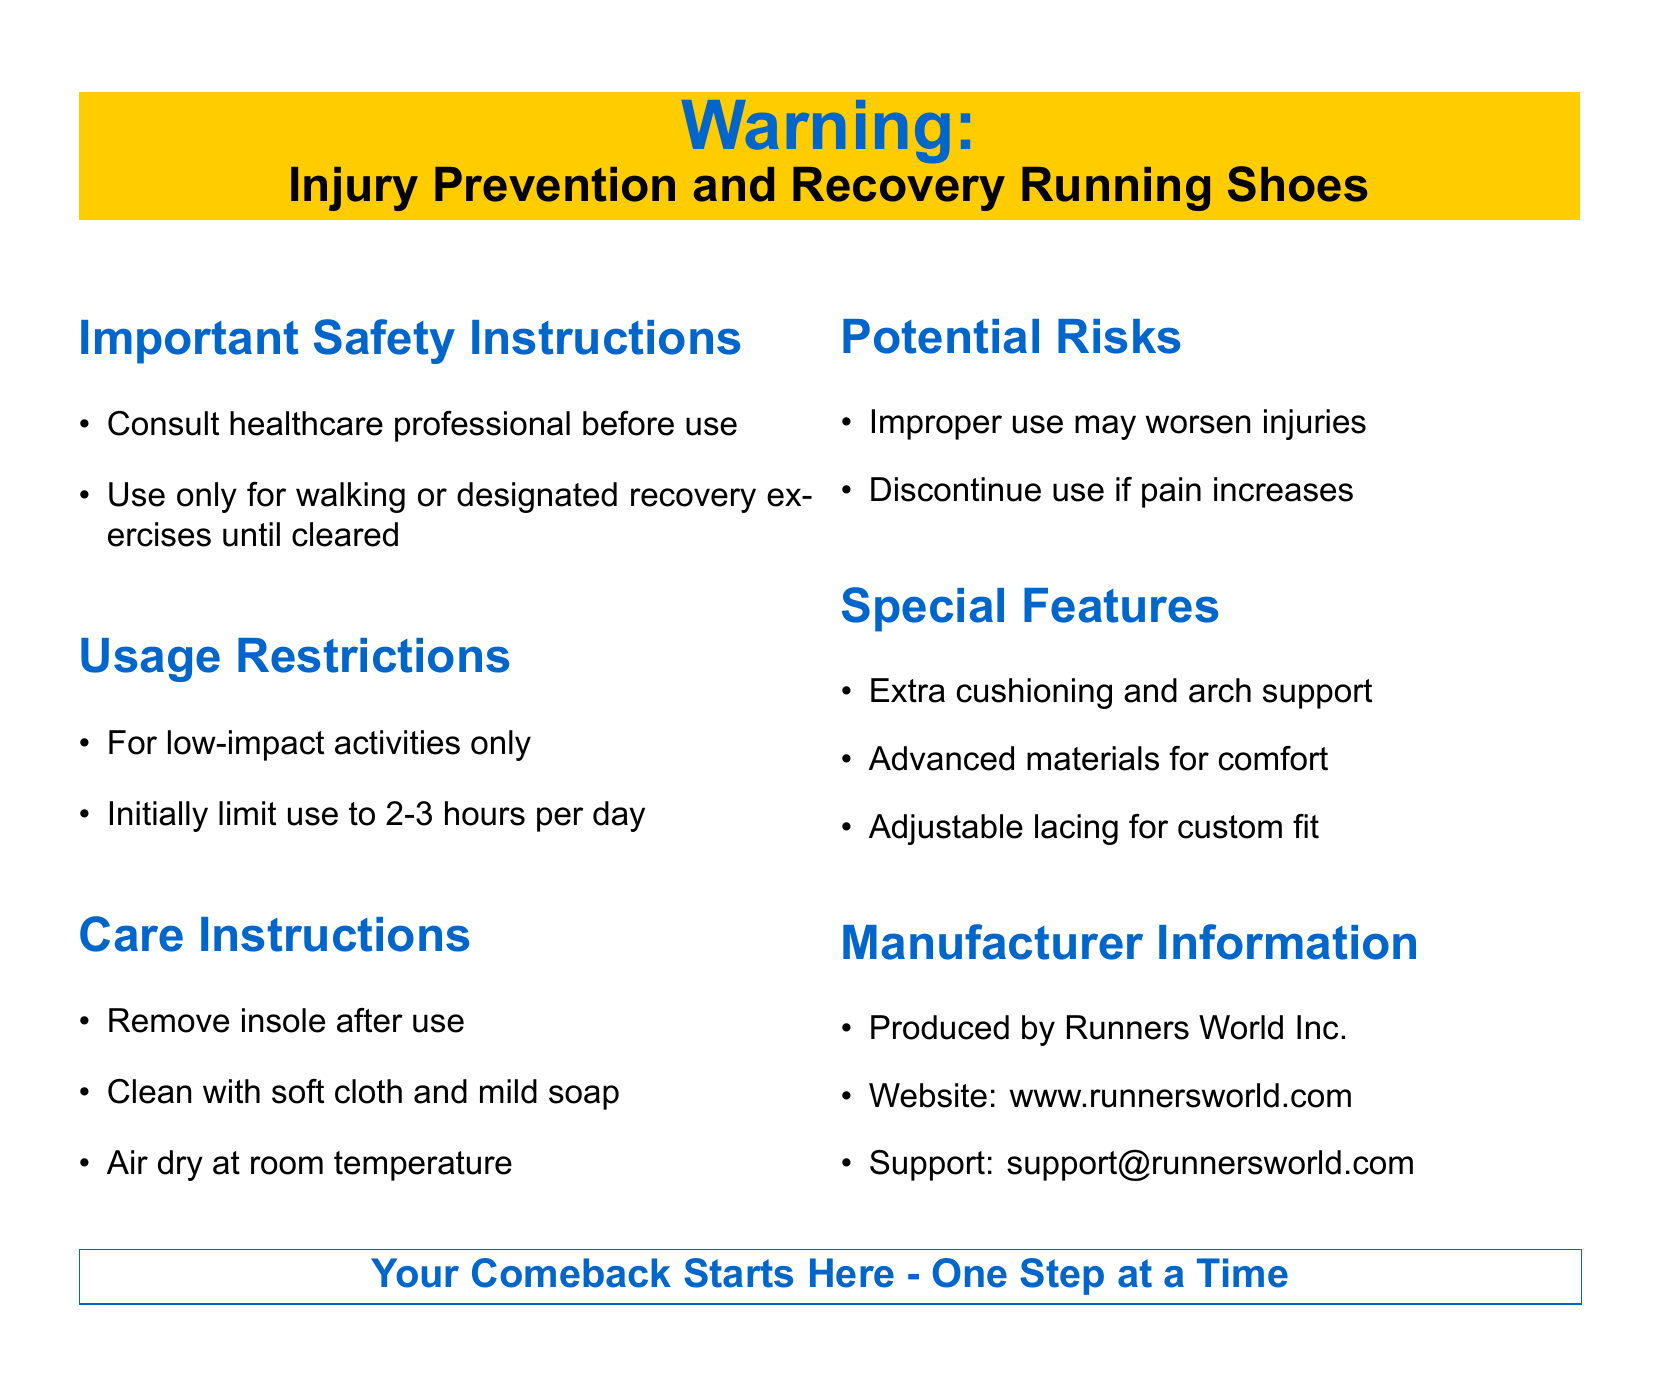What is the product type? The document specifies the product as "Injury Prevention and Recovery Running Shoes".
Answer: Injury Prevention and Recovery Running Shoes Who should you consult before use? The document advises consulting a "healthcare professional" before using the shoes.
Answer: healthcare professional What is the usage restriction for the shoes? The shoes are restricted to "low-impact activities only."
Answer: low-impact activities only What is the maximum recommended daily usage? The recommended daily usage limit is "2-3 hours per day."
Answer: 2-3 hours per day What should you do if pain increases? The document states to "discontinue use" if pain increases.
Answer: discontinue use What is one of the special features of the shoes? The shoes offer "extra cushioning and arch support" as a special feature.
Answer: extra cushioning and arch support What should be done after each use? The care instruction states to "remove insole after use."
Answer: remove insole after use Who is the manufacturer of the shoes? The document lists the manufacturer as "Runners World Inc."
Answer: Runners World Inc What is the support contact method? The document states the support contact method is "support@runnersworld.com."
Answer: support@runnersworld.com 